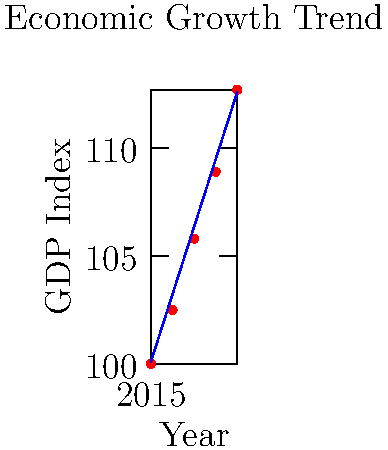Given the economic growth chart above showing the GDP index from 2015 to 2019, calculate the slope of the trend line. Round your answer to two decimal places. To calculate the slope of the trend line, we'll use the formula:

$$ \text{Slope} = \frac{y_2 - y_1}{x_2 - x_1} $$

Where $(x_1, y_1)$ is the starting point and $(x_2, y_2)$ is the ending point of the trend line.

Steps:
1. Identify the coordinates of the start and end points of the trend line:
   Start point $(x_1, y_1)$: $(2015, 100.1)$
   End point $(x_2, y_2)$: $(2019, 112.6)$

2. Substitute these values into the slope formula:
   $$ \text{Slope} = \frac{112.6 - 100.1}{2019 - 2015} = \frac{12.5}{4} $$

3. Perform the division:
   $$ \text{Slope} = 3.125 $$

4. Round to two decimal places:
   $$ \text{Slope} \approx 3.13 $$

The slope represents the average annual increase in the GDP index over the given period.
Answer: 3.13 